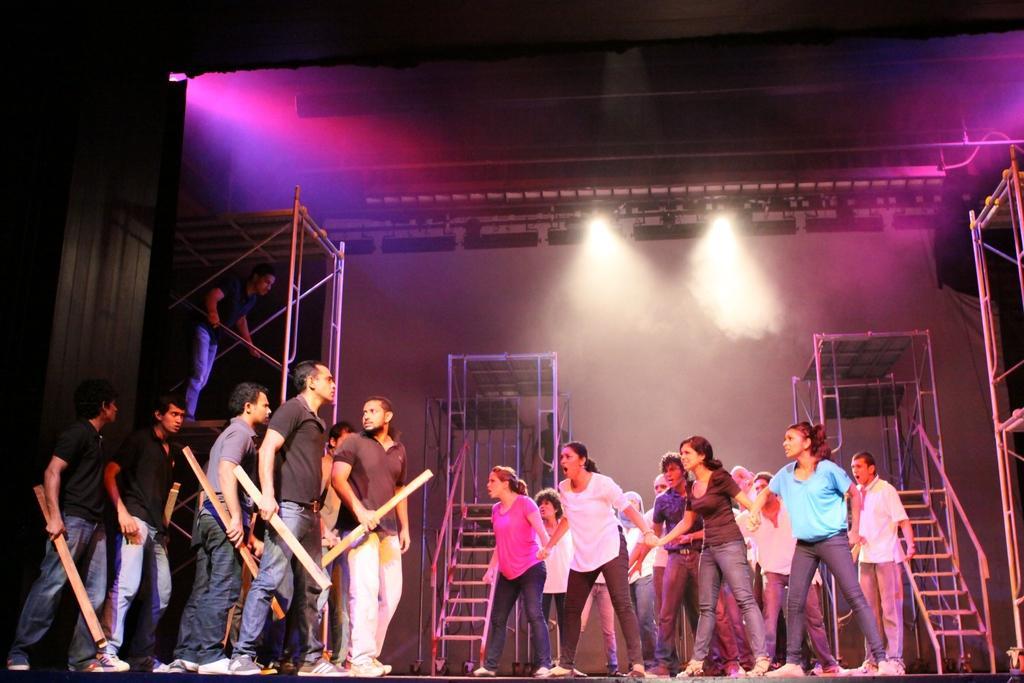Can you describe this image briefly? In this image I can see people standing, people standing on the left are wearing black t shirt and holding sticks in their hands. There are stairs at the back and there are lights at the top. 